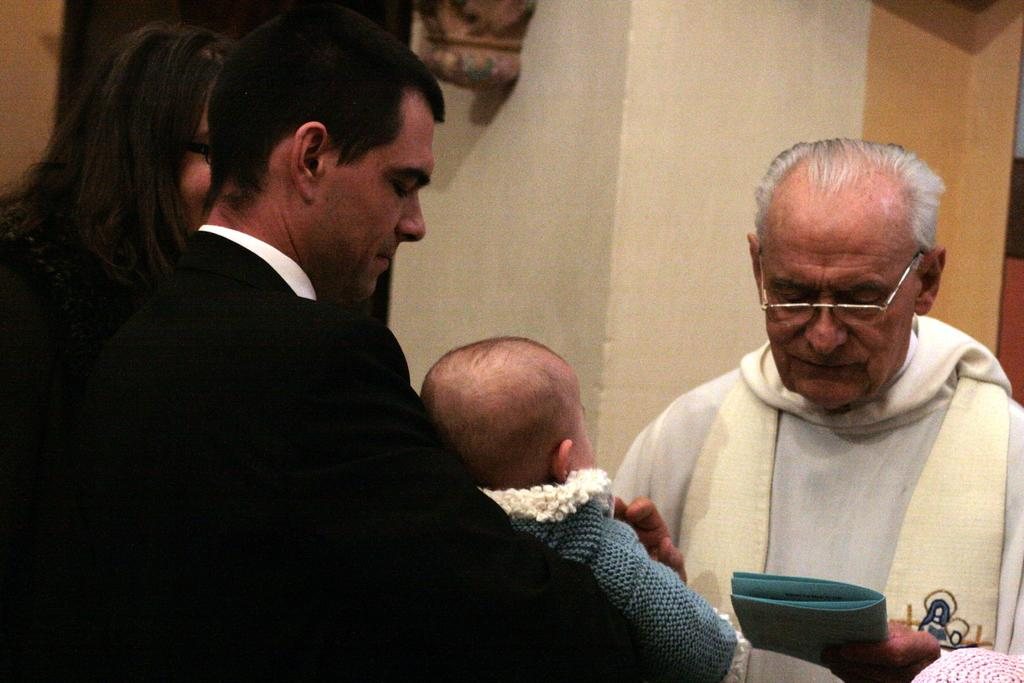How many people are in the image? There are people in the image, but the exact number is not specified. What are the people doing in the image? One person is holding a baby, and another person is holding a book. What can be seen in the background of the image? There is a wall visible in the background of the image. Can you tell me how many people are swimming in the image? There is no indication of swimming or any body of water in the image. What type of ship can be seen in the background of the image? There is no ship present in the image; only a wall is visible in the background. 